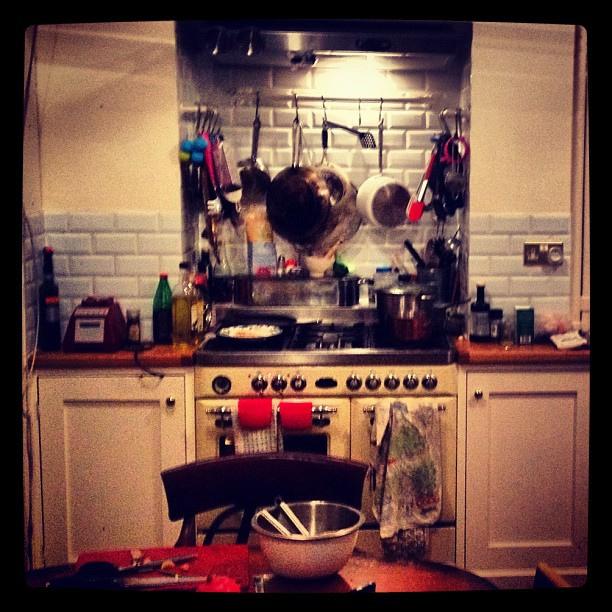What sort of backsplash is there?
Be succinct. Brick. Is the stove new?
Give a very brief answer. No. What meal are they making?
Answer briefly. Breakfast. 